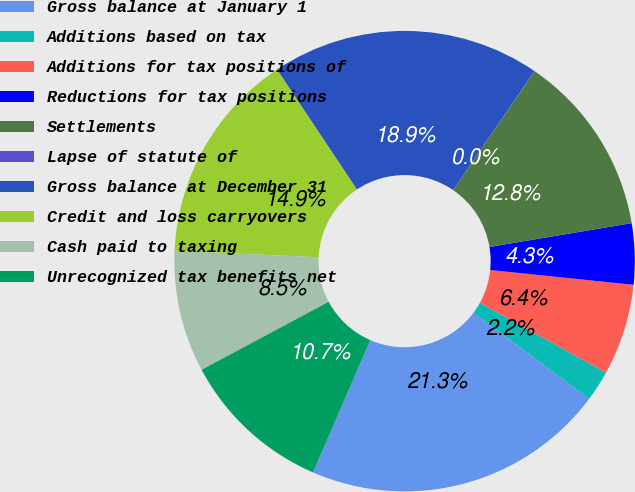Convert chart. <chart><loc_0><loc_0><loc_500><loc_500><pie_chart><fcel>Gross balance at January 1<fcel>Additions based on tax<fcel>Additions for tax positions of<fcel>Reductions for tax positions<fcel>Settlements<fcel>Lapse of statute of<fcel>Gross balance at December 31<fcel>Credit and loss carryovers<fcel>Cash paid to taxing<fcel>Unrecognized tax benefits net<nl><fcel>21.31%<fcel>2.15%<fcel>6.41%<fcel>4.28%<fcel>12.8%<fcel>0.02%<fcel>18.89%<fcel>14.93%<fcel>8.54%<fcel>10.67%<nl></chart> 